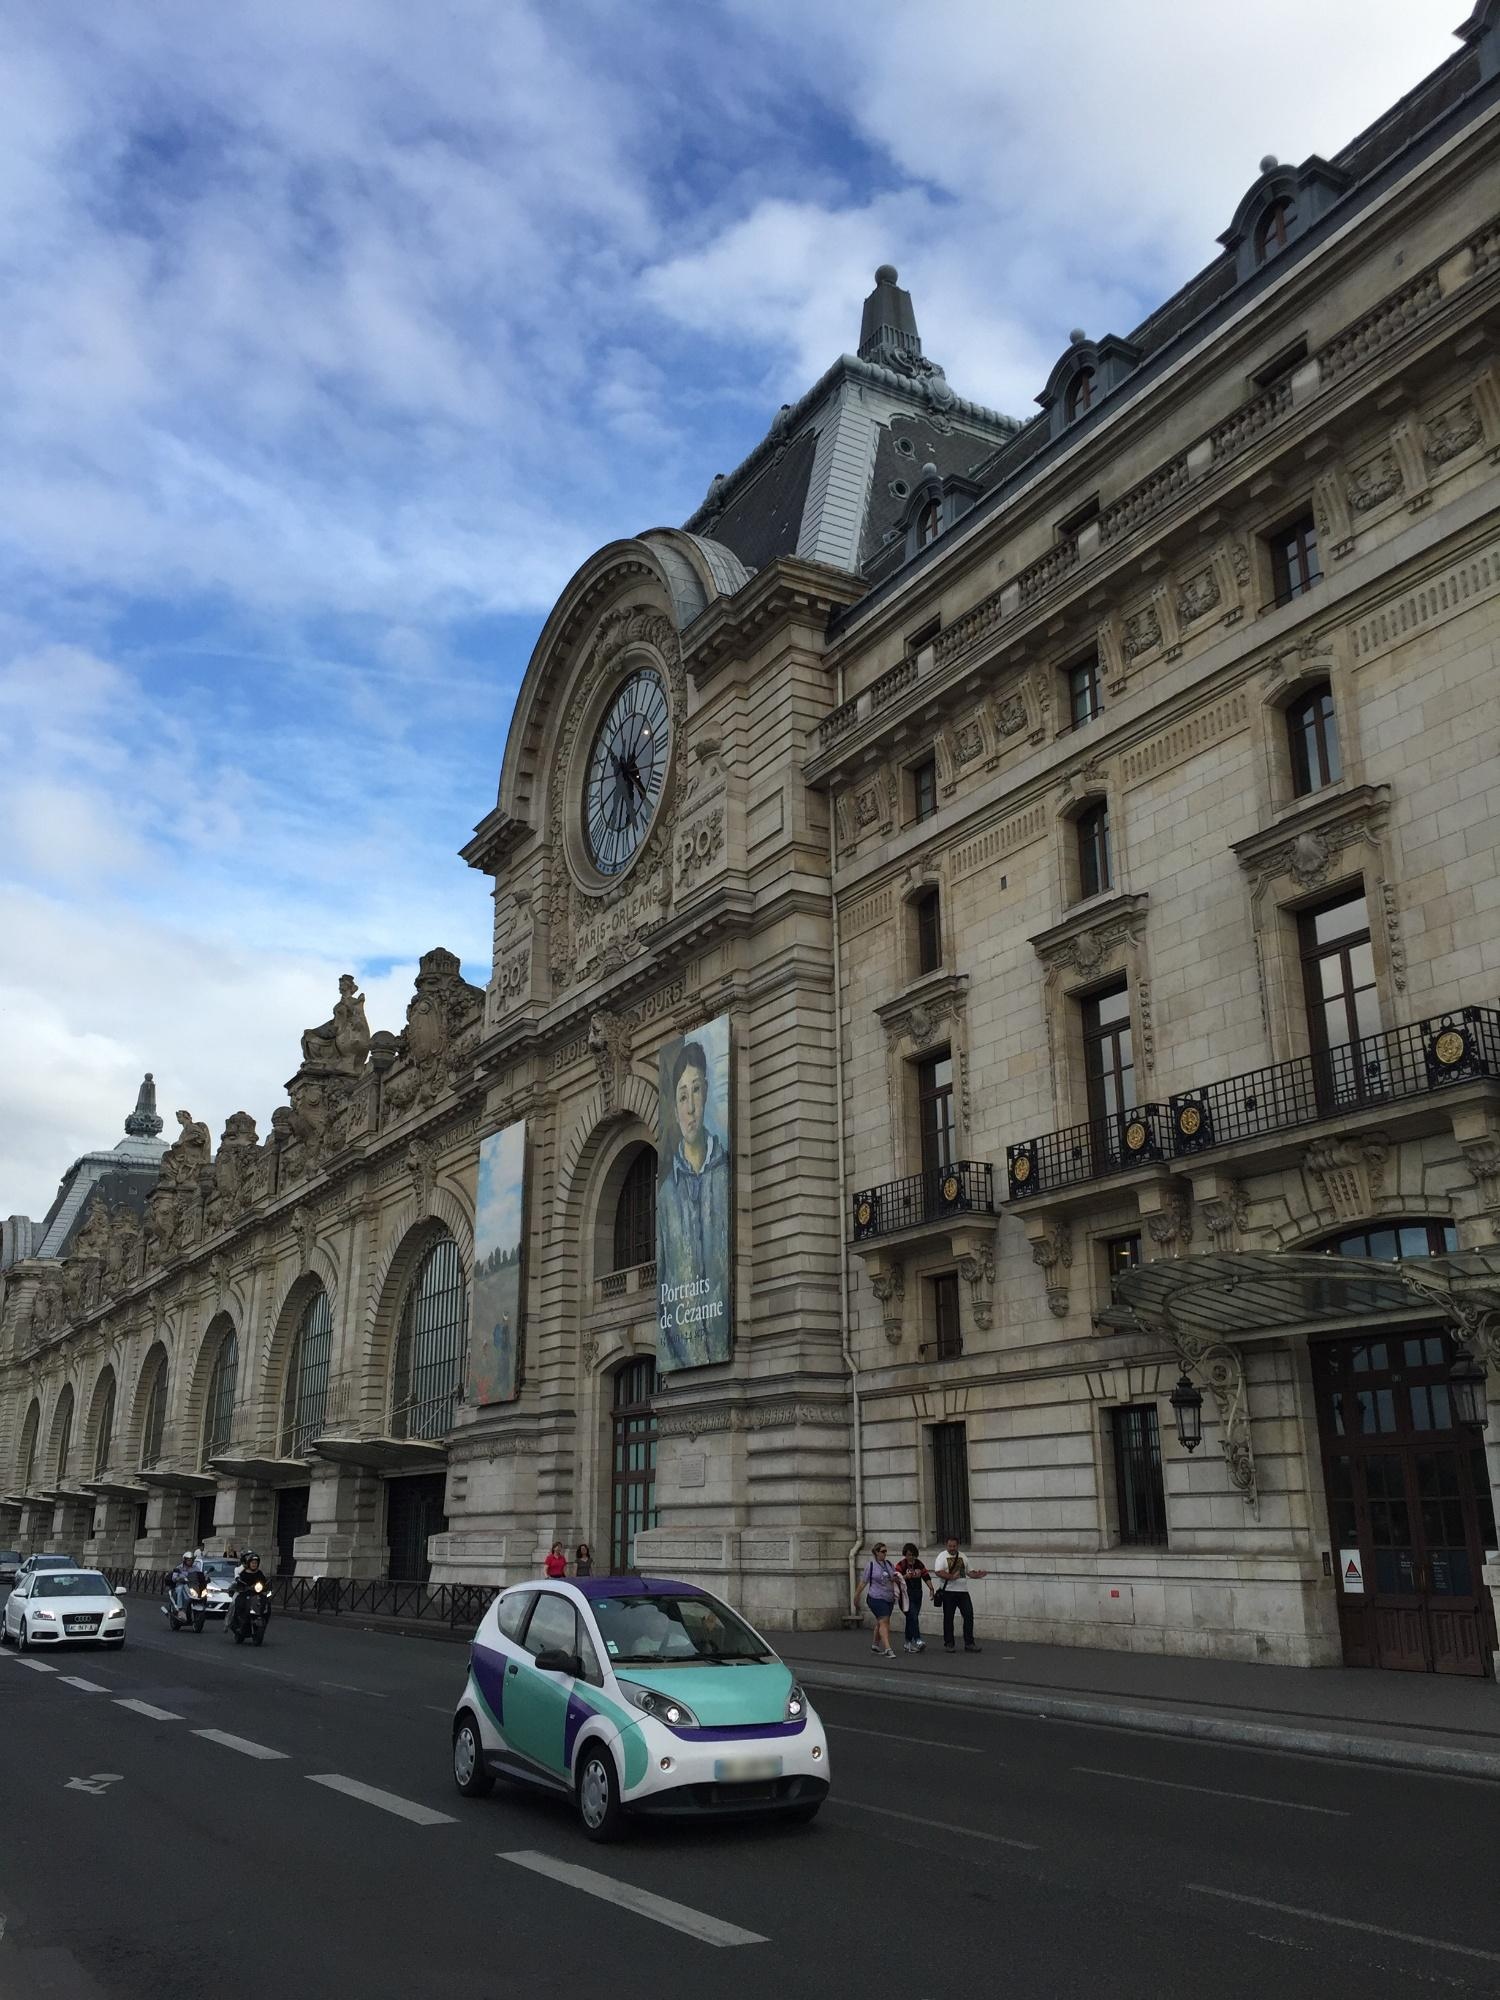Can you explain the history of the building shown in this photo? Certainly! The building in the photo is the Musée d'Orsay, located in Paris, France. Originally built as a railway station in 1900, the Gare d'Orsay primarily served the southwest regions of France. As train sizes grew and the station became unsuitable for newer, longer trains, its operations wound down and it was ultimately closed in 1939. After serving various roles throughout the mid-20th century, including a mailing center during World War II, it was transformed into a museum in 1986. The museum now houses art from the period of 1848 to 1914, including famous works by painters like Monet, Degas, and Van Gogh. Why is the large clock so prominent in the building's design? The large clock is a significant feature that hints at the building's original purpose as a railway station. This architectural element serves not only as a functional timepiece for travelers but also as a symbolic reminder of the passage of time. It's prominently placed on the facade, overlooking the city and providing a visual landmark. In its current role as a museum, the clock also metaphorically represents the preservation and presentation of historical periods, encapsulating moments in art history as the clock once did for moments in time for travelers. 